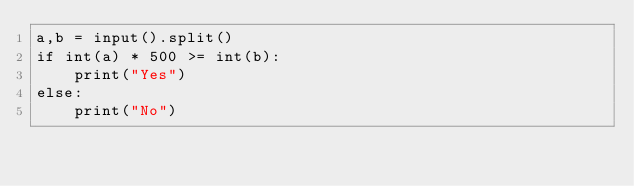<code> <loc_0><loc_0><loc_500><loc_500><_Python_>a,b = input().split()
if int(a) * 500 >= int(b):
    print("Yes")
else:
    print("No")</code> 